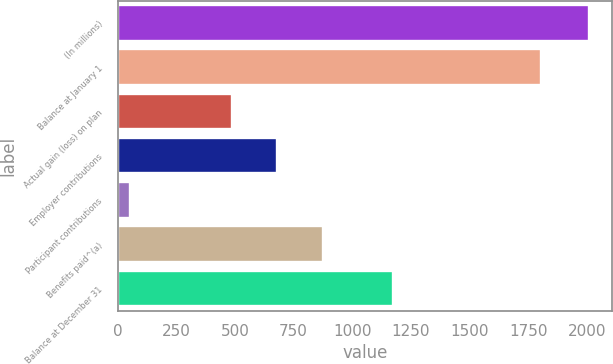<chart> <loc_0><loc_0><loc_500><loc_500><bar_chart><fcel>(In millions)<fcel>Balance at January 1<fcel>Actual gain (loss) on plan<fcel>Employer contributions<fcel>Participant contributions<fcel>Benefits paid^(a)<fcel>Balance at December 31<nl><fcel>2008<fcel>1804<fcel>486<fcel>681.7<fcel>51<fcel>877.4<fcel>1175<nl></chart> 